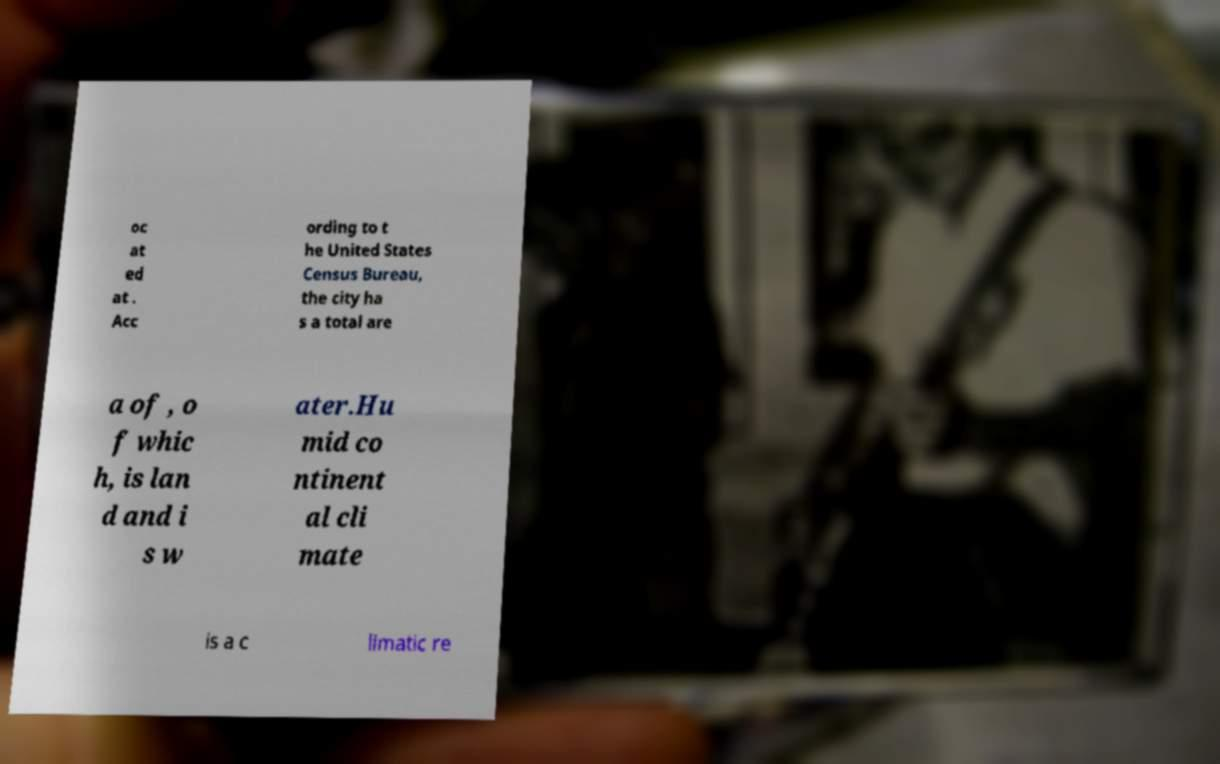What messages or text are displayed in this image? I need them in a readable, typed format. oc at ed at . Acc ording to t he United States Census Bureau, the city ha s a total are a of , o f whic h, is lan d and i s w ater.Hu mid co ntinent al cli mate is a c limatic re 